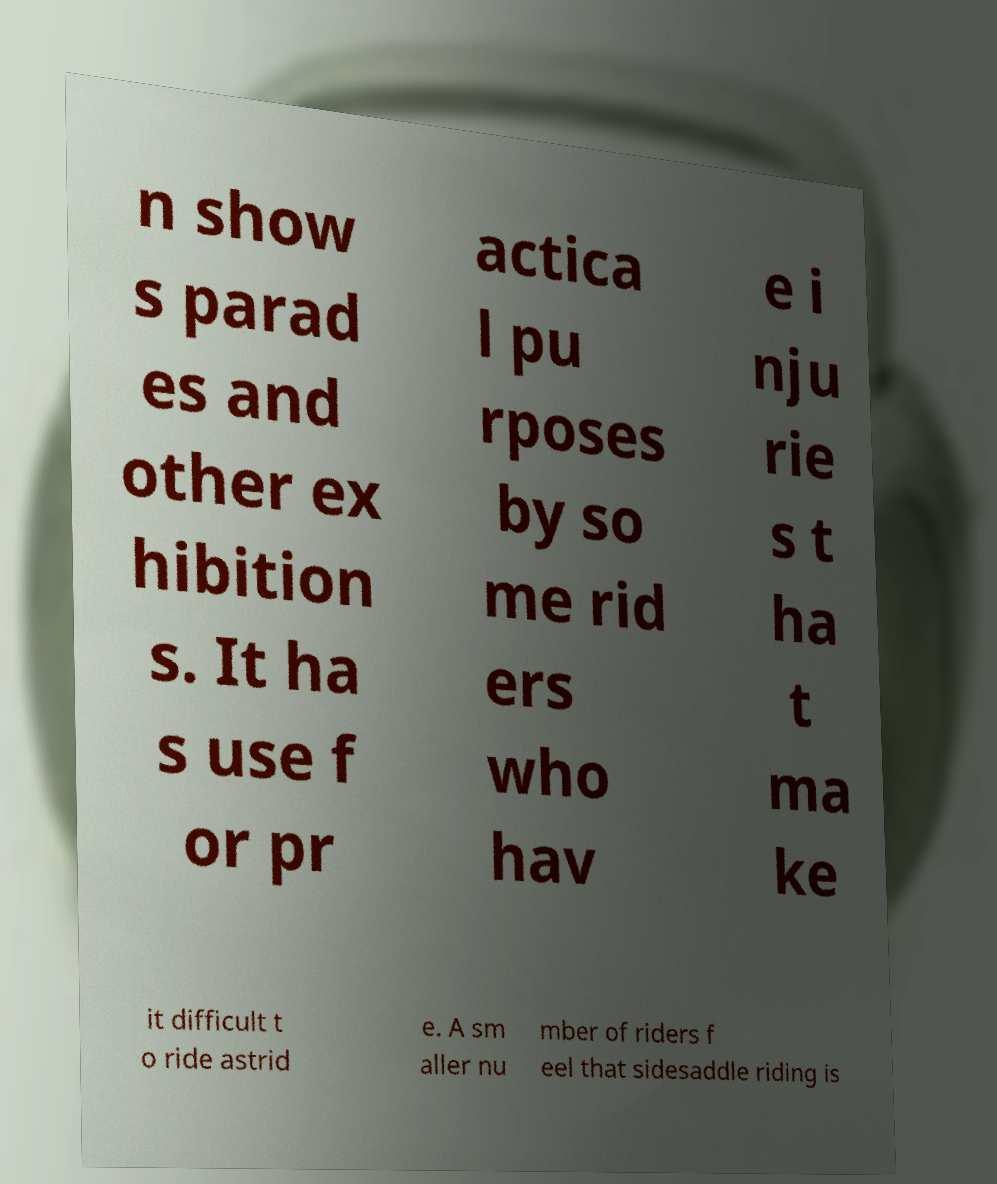Can you accurately transcribe the text from the provided image for me? n show s parad es and other ex hibition s. It ha s use f or pr actica l pu rposes by so me rid ers who hav e i nju rie s t ha t ma ke it difficult t o ride astrid e. A sm aller nu mber of riders f eel that sidesaddle riding is 